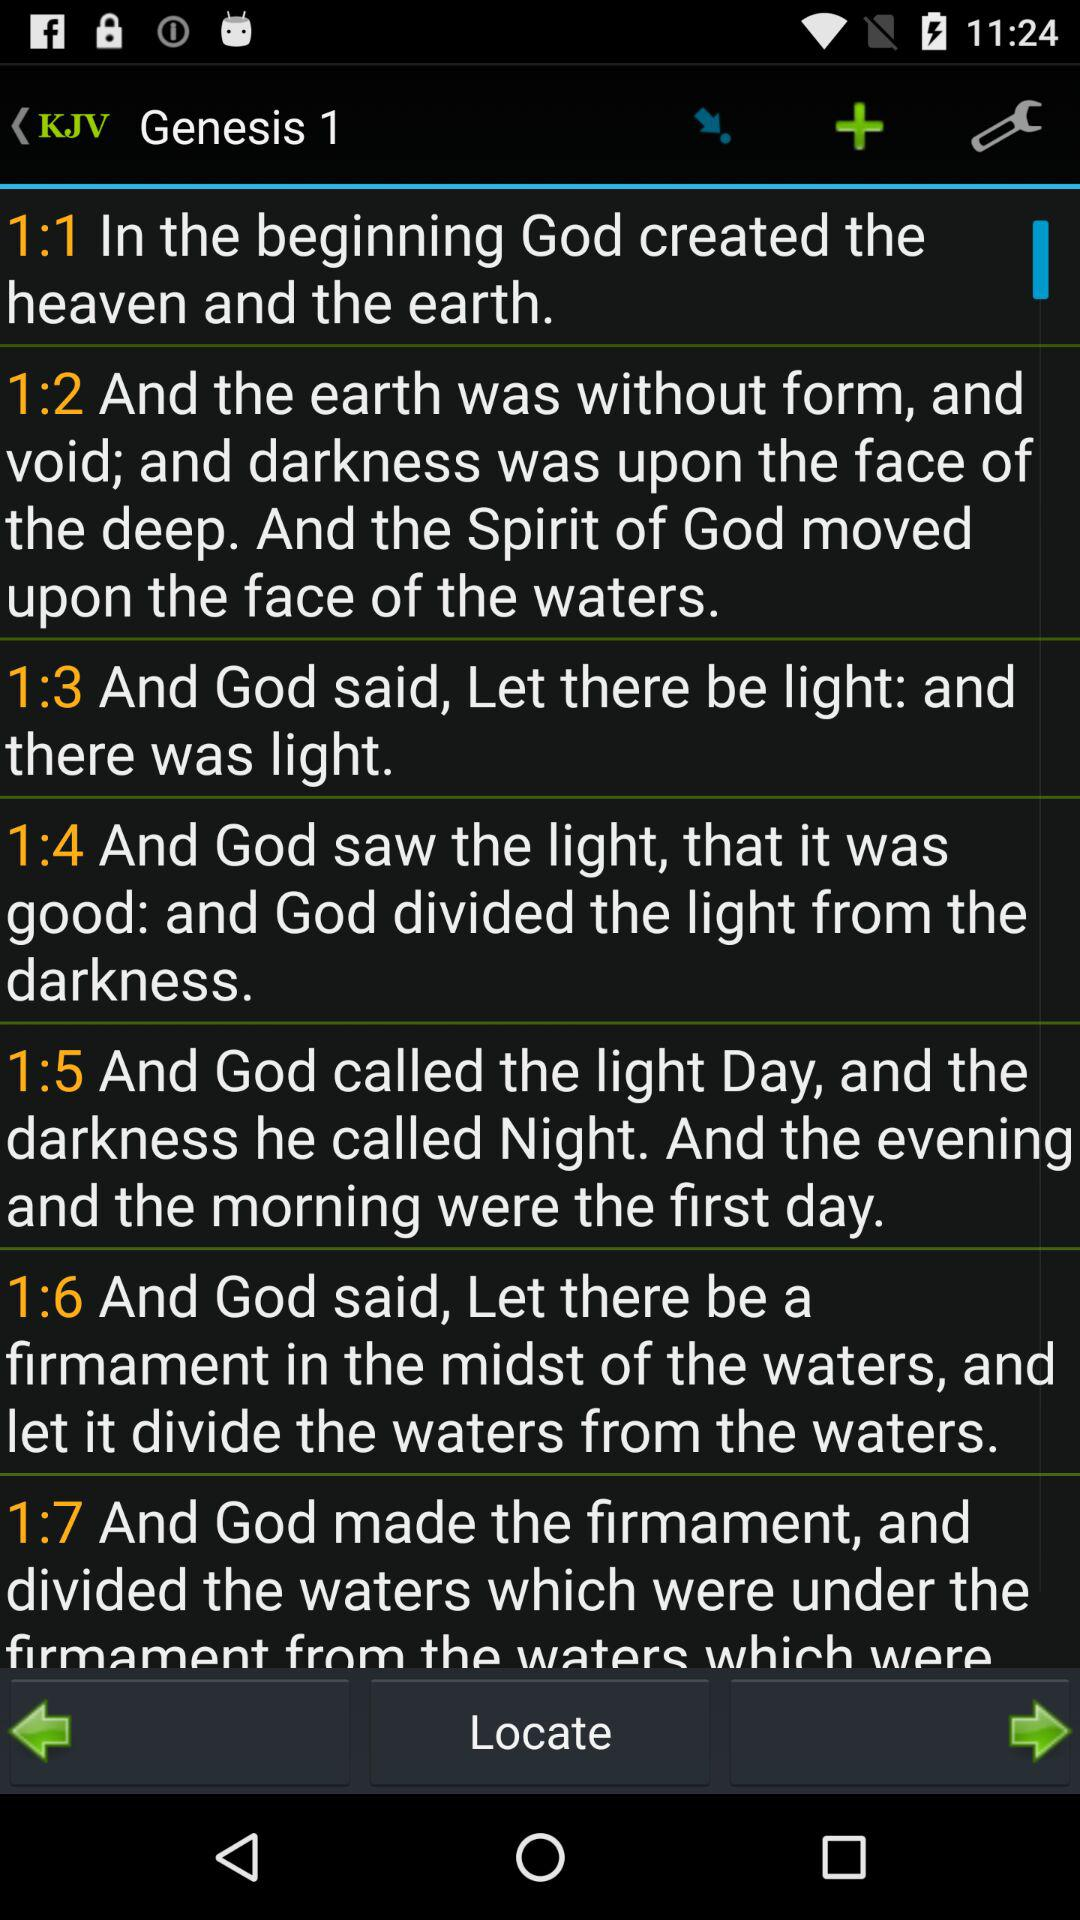What is the light called by God? The light is called day by God. 